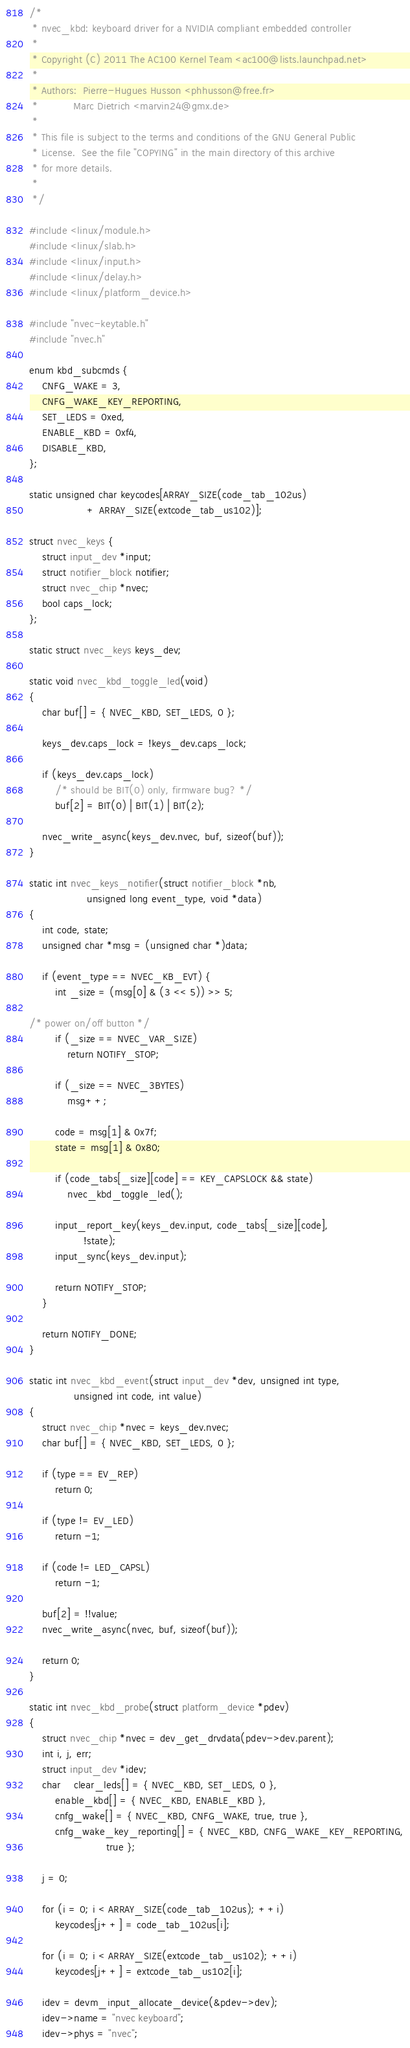Convert code to text. <code><loc_0><loc_0><loc_500><loc_500><_C_>/*
 * nvec_kbd: keyboard driver for a NVIDIA compliant embedded controller
 *
 * Copyright (C) 2011 The AC100 Kernel Team <ac100@lists.launchpad.net>
 *
 * Authors:  Pierre-Hugues Husson <phhusson@free.fr>
 *           Marc Dietrich <marvin24@gmx.de>
 *
 * This file is subject to the terms and conditions of the GNU General Public
 * License.  See the file "COPYING" in the main directory of this archive
 * for more details.
 *
 */

#include <linux/module.h>
#include <linux/slab.h>
#include <linux/input.h>
#include <linux/delay.h>
#include <linux/platform_device.h>

#include "nvec-keytable.h"
#include "nvec.h"

enum kbd_subcmds {
	CNFG_WAKE = 3,
	CNFG_WAKE_KEY_REPORTING,
	SET_LEDS = 0xed,
	ENABLE_KBD = 0xf4,
	DISABLE_KBD,
};

static unsigned char keycodes[ARRAY_SIZE(code_tab_102us)
			      + ARRAY_SIZE(extcode_tab_us102)];

struct nvec_keys {
	struct input_dev *input;
	struct notifier_block notifier;
	struct nvec_chip *nvec;
	bool caps_lock;
};

static struct nvec_keys keys_dev;

static void nvec_kbd_toggle_led(void)
{
	char buf[] = { NVEC_KBD, SET_LEDS, 0 };

	keys_dev.caps_lock = !keys_dev.caps_lock;

	if (keys_dev.caps_lock)
		/* should be BIT(0) only, firmware bug? */
		buf[2] = BIT(0) | BIT(1) | BIT(2);

	nvec_write_async(keys_dev.nvec, buf, sizeof(buf));
}

static int nvec_keys_notifier(struct notifier_block *nb,
			      unsigned long event_type, void *data)
{
	int code, state;
	unsigned char *msg = (unsigned char *)data;

	if (event_type == NVEC_KB_EVT) {
		int _size = (msg[0] & (3 << 5)) >> 5;

/* power on/off button */
		if (_size == NVEC_VAR_SIZE)
			return NOTIFY_STOP;

		if (_size == NVEC_3BYTES)
			msg++;

		code = msg[1] & 0x7f;
		state = msg[1] & 0x80;

		if (code_tabs[_size][code] == KEY_CAPSLOCK && state)
			nvec_kbd_toggle_led();

		input_report_key(keys_dev.input, code_tabs[_size][code],
				 !state);
		input_sync(keys_dev.input);

		return NOTIFY_STOP;
	}

	return NOTIFY_DONE;
}

static int nvec_kbd_event(struct input_dev *dev, unsigned int type,
			  unsigned int code, int value)
{
	struct nvec_chip *nvec = keys_dev.nvec;
	char buf[] = { NVEC_KBD, SET_LEDS, 0 };

	if (type == EV_REP)
		return 0;

	if (type != EV_LED)
		return -1;

	if (code != LED_CAPSL)
		return -1;

	buf[2] = !!value;
	nvec_write_async(nvec, buf, sizeof(buf));

	return 0;
}

static int nvec_kbd_probe(struct platform_device *pdev)
{
	struct nvec_chip *nvec = dev_get_drvdata(pdev->dev.parent);
	int i, j, err;
	struct input_dev *idev;
	char	clear_leds[] = { NVEC_KBD, SET_LEDS, 0 },
		enable_kbd[] = { NVEC_KBD, ENABLE_KBD },
		cnfg_wake[] = { NVEC_KBD, CNFG_WAKE, true, true },
		cnfg_wake_key_reporting[] = { NVEC_KBD, CNFG_WAKE_KEY_REPORTING,
						true };

	j = 0;

	for (i = 0; i < ARRAY_SIZE(code_tab_102us); ++i)
		keycodes[j++] = code_tab_102us[i];

	for (i = 0; i < ARRAY_SIZE(extcode_tab_us102); ++i)
		keycodes[j++] = extcode_tab_us102[i];

	idev = devm_input_allocate_device(&pdev->dev);
	idev->name = "nvec keyboard";
	idev->phys = "nvec";</code> 